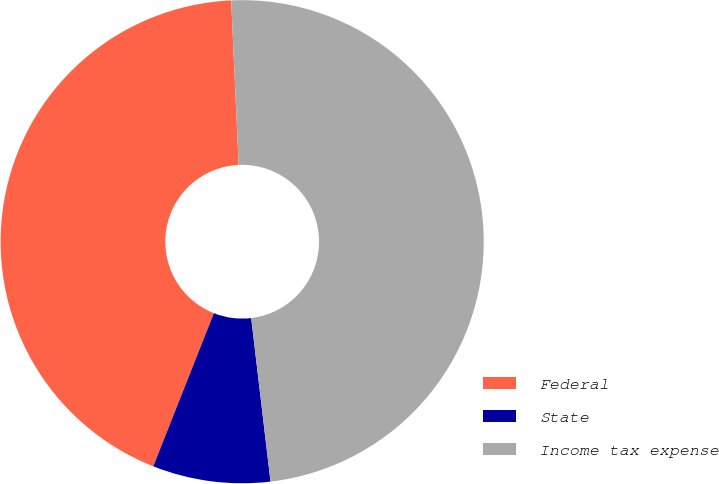Convert chart. <chart><loc_0><loc_0><loc_500><loc_500><pie_chart><fcel>Federal<fcel>State<fcel>Income tax expense<nl><fcel>43.28%<fcel>7.87%<fcel>48.85%<nl></chart> 